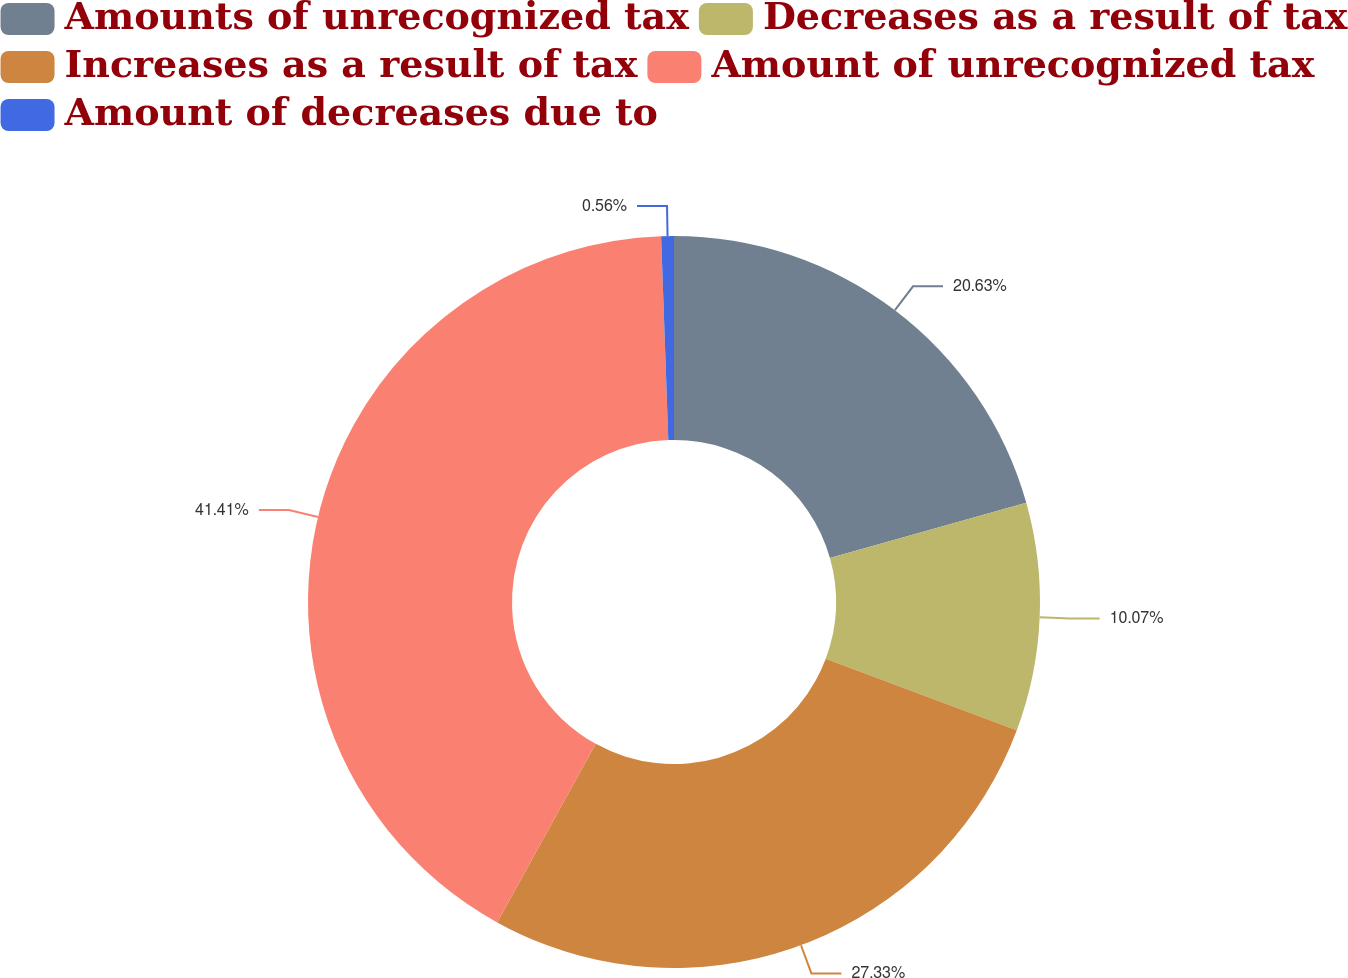<chart> <loc_0><loc_0><loc_500><loc_500><pie_chart><fcel>Amounts of unrecognized tax<fcel>Decreases as a result of tax<fcel>Increases as a result of tax<fcel>Amount of unrecognized tax<fcel>Amount of decreases due to<nl><fcel>20.63%<fcel>10.07%<fcel>27.33%<fcel>41.42%<fcel>0.56%<nl></chart> 